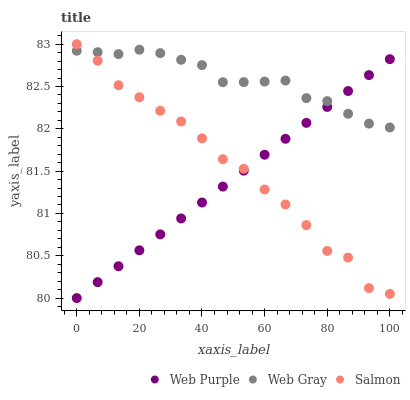Does Web Purple have the minimum area under the curve?
Answer yes or no. Yes. Does Web Gray have the maximum area under the curve?
Answer yes or no. Yes. Does Salmon have the minimum area under the curve?
Answer yes or no. No. Does Salmon have the maximum area under the curve?
Answer yes or no. No. Is Web Purple the smoothest?
Answer yes or no. Yes. Is Salmon the roughest?
Answer yes or no. Yes. Is Web Gray the smoothest?
Answer yes or no. No. Is Web Gray the roughest?
Answer yes or no. No. Does Web Purple have the lowest value?
Answer yes or no. Yes. Does Salmon have the lowest value?
Answer yes or no. No. Does Salmon have the highest value?
Answer yes or no. Yes. Does Web Gray have the highest value?
Answer yes or no. No. Does Salmon intersect Web Purple?
Answer yes or no. Yes. Is Salmon less than Web Purple?
Answer yes or no. No. Is Salmon greater than Web Purple?
Answer yes or no. No. 